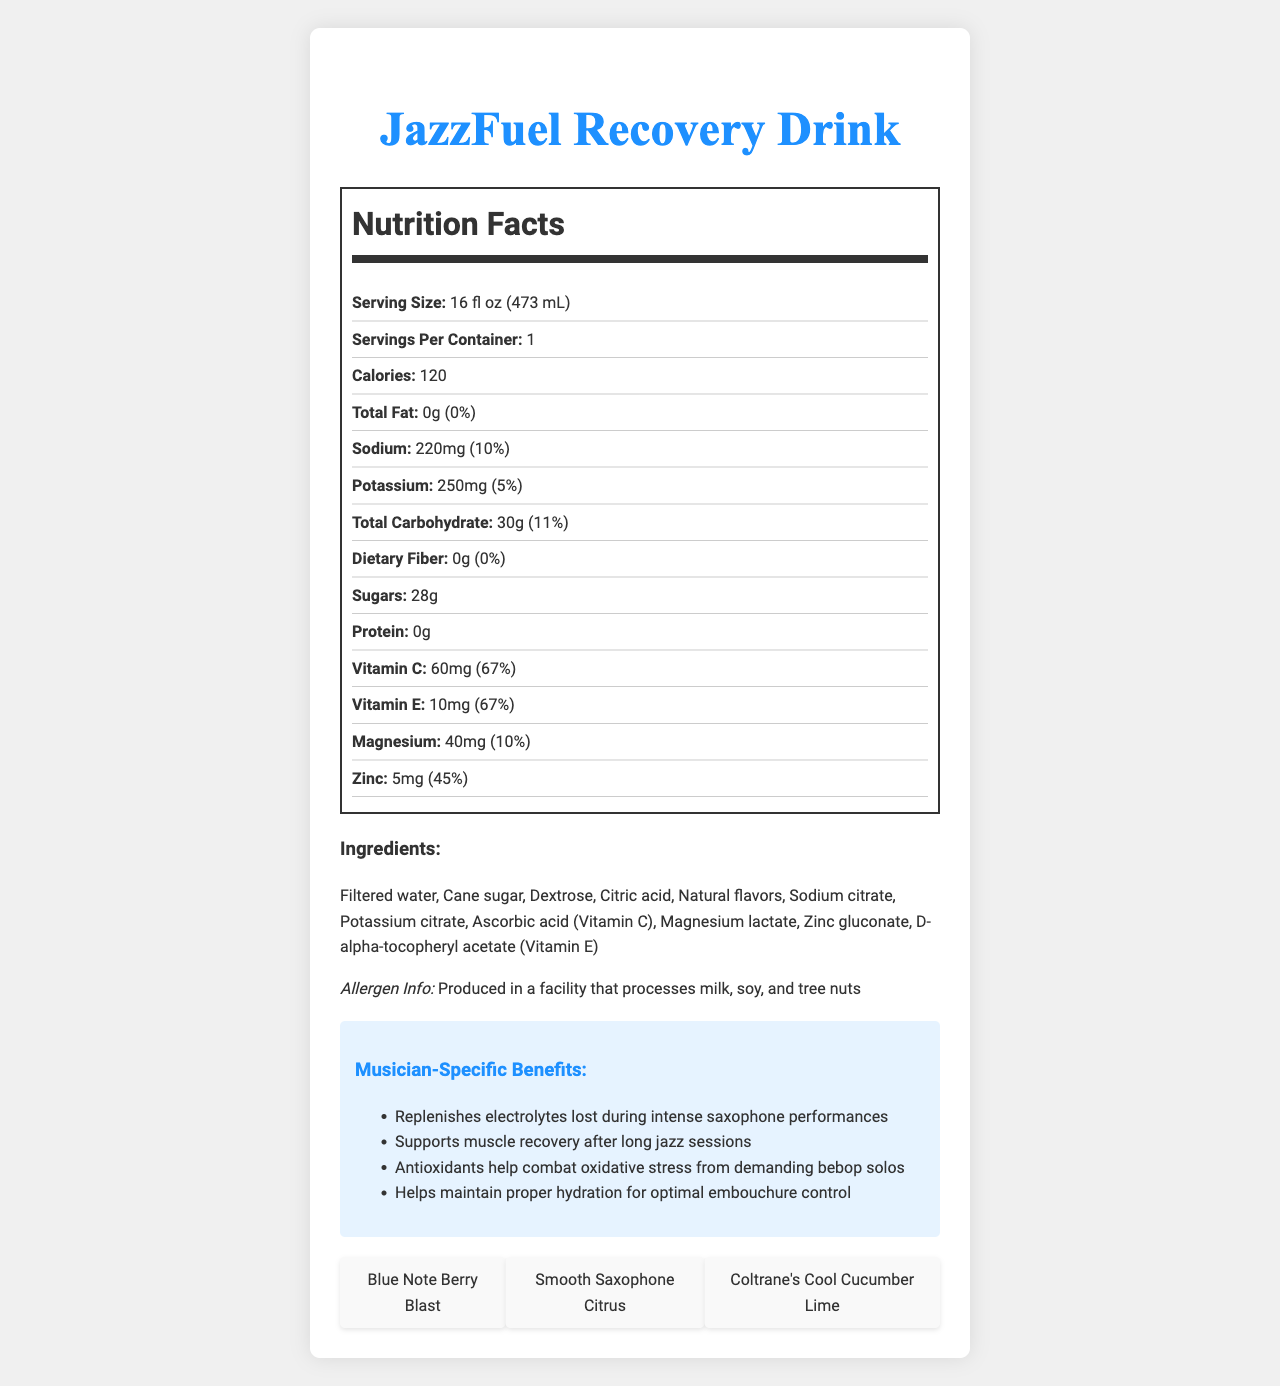what is the serving size? The serving size is listed as 16 fl oz (473 mL) in the Nutrition Facts section.
Answer: 16 fl oz (473 mL) How many grams of total carbohydrates are in one serving? The total carbohydrate content per serving is listed as 30g.
Answer: 30g What percentage of the daily value of Vitamin C does one serving provide? One serving provides 67% of the daily value of Vitamin C.
Answer: 67% How much sodium is in one serving? The amount of sodium per serving is listed as 220mg.
Answer: 220mg Are there any proteins in the JazzFuel Recovery Drink? The protein content per serving is listed as 0g, indicating no proteins are present.
Answer: No Which vitamin has the highest percentage of daily value per serving? A. Vitamin C B. Vitamin E C. Magnesium D. Zinc Vitamin C has 67% of the daily value per serving, which is the highest percentage listed.
Answer: A. Vitamin C What is the dominant type of sugar used in the drink? A. Cane Sugar B. Fructose C. Dextrose D. High Fructose Corn Syrup Cane sugar and dextrose are listed as ingredients, but cane sugar is the first mentioned, indicating it is used in a higher quantity.
Answer: A. Cane Sugar Is the drink suitable for someone allergic to tree nuts? The product is produced in a facility that processes milk, soy, and tree nuts, which is mentioned in the allergen information section.
Answer: No Summarize the main benefits of the JazzFuel Recovery Drink for musicians. The musician-specific benefits section lists that the drink replenishes electrolytes, supports muscle recovery, helps combat oxidative stress, and maintains proper hydration, all of which are advantageous for musicians, especially after intense performances.
Answer: Helps replenish electrolytes, support muscle recovery, combat oxidative stress, and maintain hydration. What is the source of Vitamin E in the drink? The ingredient section lists D-alpha-tocopheryl acetate as the source of Vitamin E.
Answer: D-alpha-tocopheryl acetate List the flavors inspired by jazz. The document lists three jazz-inspired flavors: Blue Note Berry Blast, Smooth Saxophone Citrus, and Coltrane's Cool Cucumber Lime.
Answer: Blue Note Berry Blast, Smooth Saxophone Citrus, Coltrane's Cool Cucumber Lime Can the document tell us how much potassium is recommended daily? The document provides the amount of potassium per serving and its percentage of the daily value but does not state the recommended daily amount.
Answer: Not enough information 